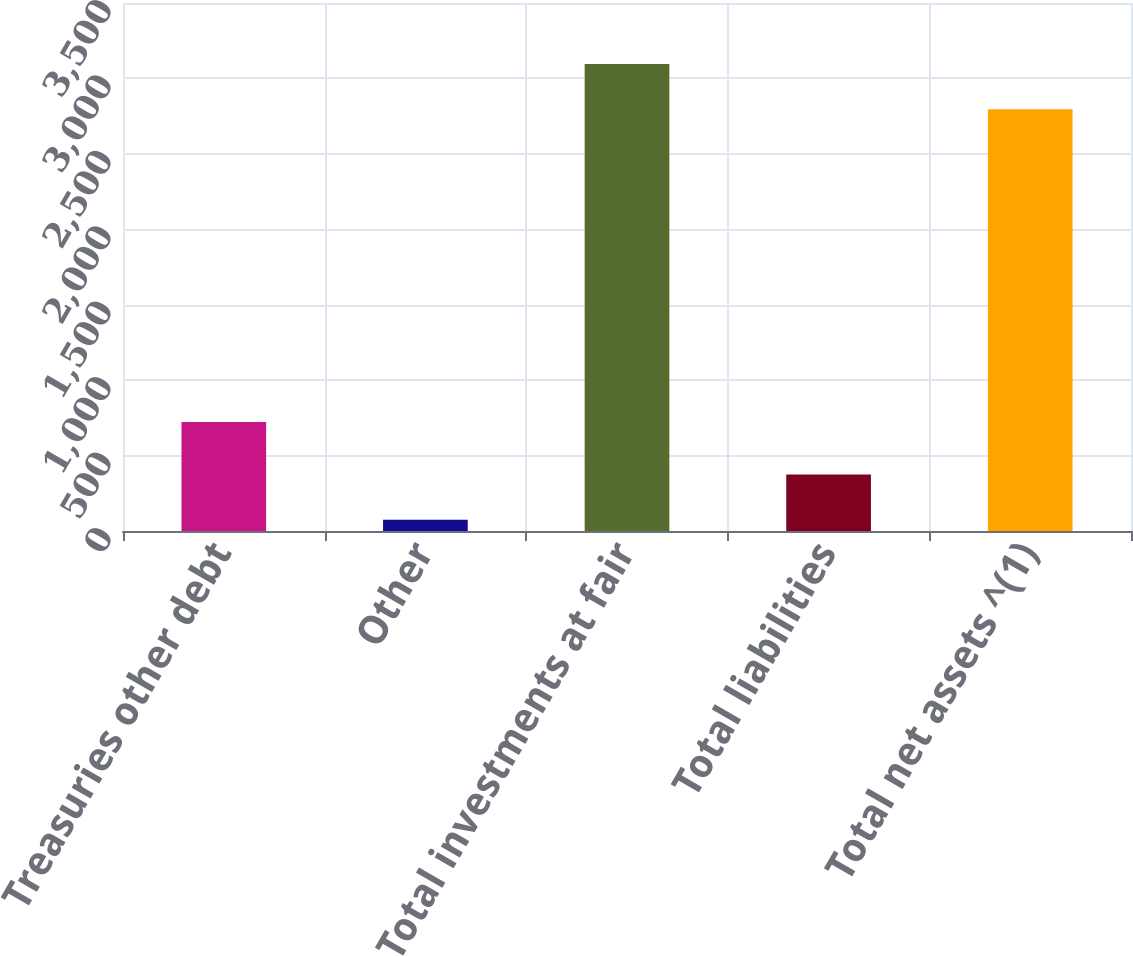<chart> <loc_0><loc_0><loc_500><loc_500><bar_chart><fcel>Treasuries other debt<fcel>Other<fcel>Total investments at fair<fcel>Total liabilities<fcel>Total net assets ^(1)<nl><fcel>723<fcel>74<fcel>3096<fcel>374<fcel>2796<nl></chart> 